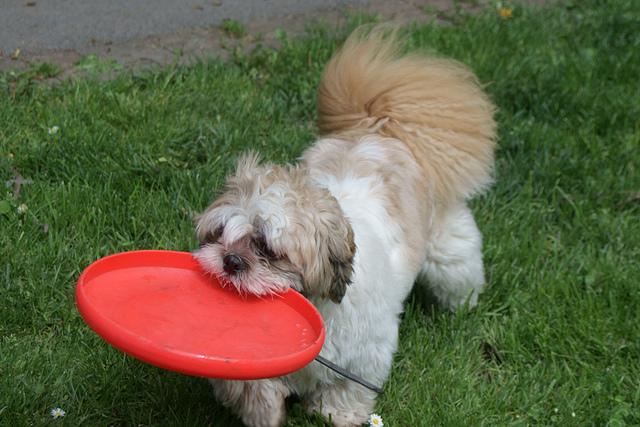Is this dog inside?
Concise answer only. No. Is the dog shaggy?
Concise answer only. Yes. What color of the freebee?
Be succinct. Red. 